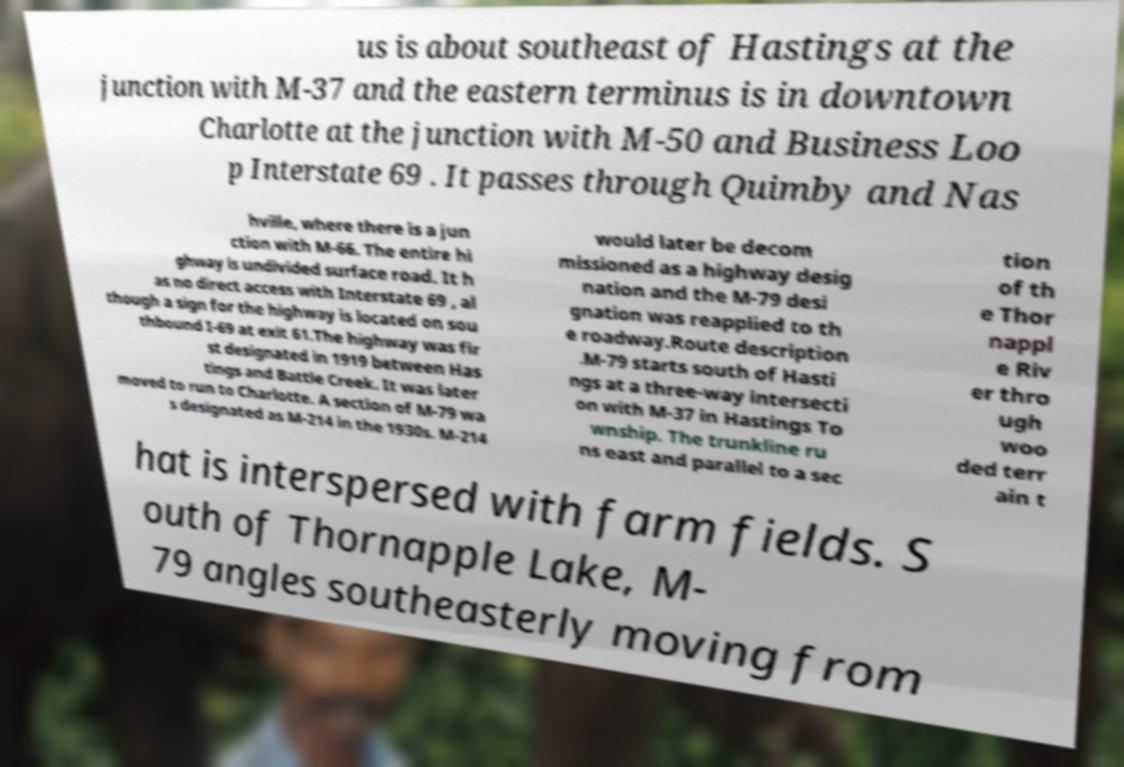Could you assist in decoding the text presented in this image and type it out clearly? us is about southeast of Hastings at the junction with M-37 and the eastern terminus is in downtown Charlotte at the junction with M-50 and Business Loo p Interstate 69 . It passes through Quimby and Nas hville, where there is a jun ction with M-66. The entire hi ghway is undivided surface road. It h as no direct access with Interstate 69 , al though a sign for the highway is located on sou thbound I-69 at exit 61.The highway was fir st designated in 1919 between Has tings and Battle Creek. It was later moved to run to Charlotte. A section of M-79 wa s designated as M-214 in the 1930s. M-214 would later be decom missioned as a highway desig nation and the M-79 desi gnation was reapplied to th e roadway.Route description .M-79 starts south of Hasti ngs at a three-way intersecti on with M-37 in Hastings To wnship. The trunkline ru ns east and parallel to a sec tion of th e Thor nappl e Riv er thro ugh woo ded terr ain t hat is interspersed with farm fields. S outh of Thornapple Lake, M- 79 angles southeasterly moving from 